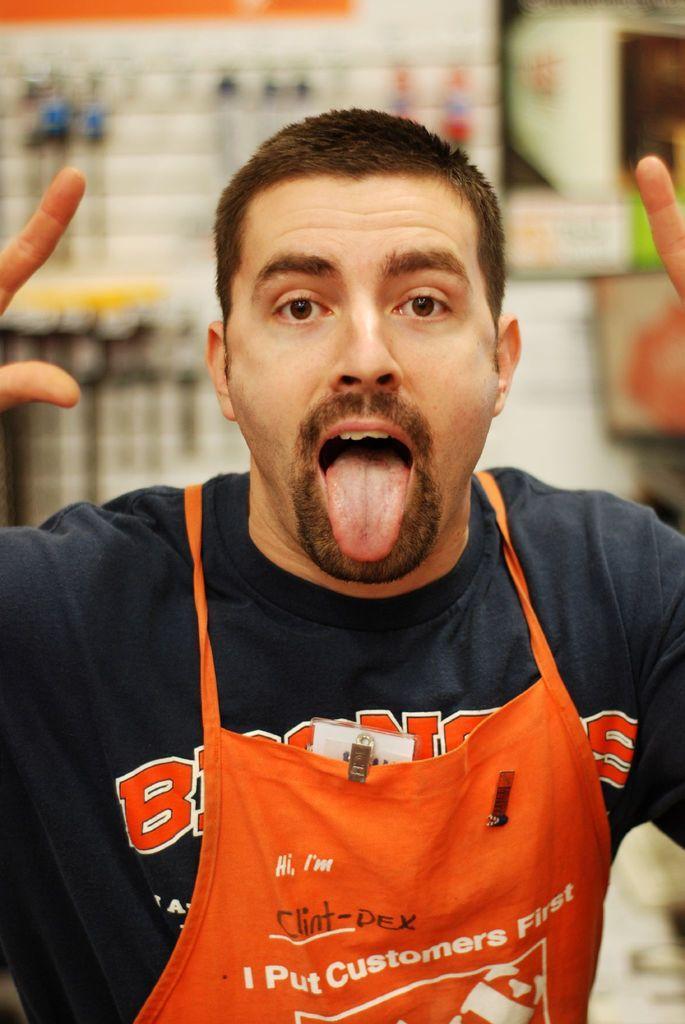Describe this image in one or two sentences. In this picture there is a man. In the background of the image it is blurry. 